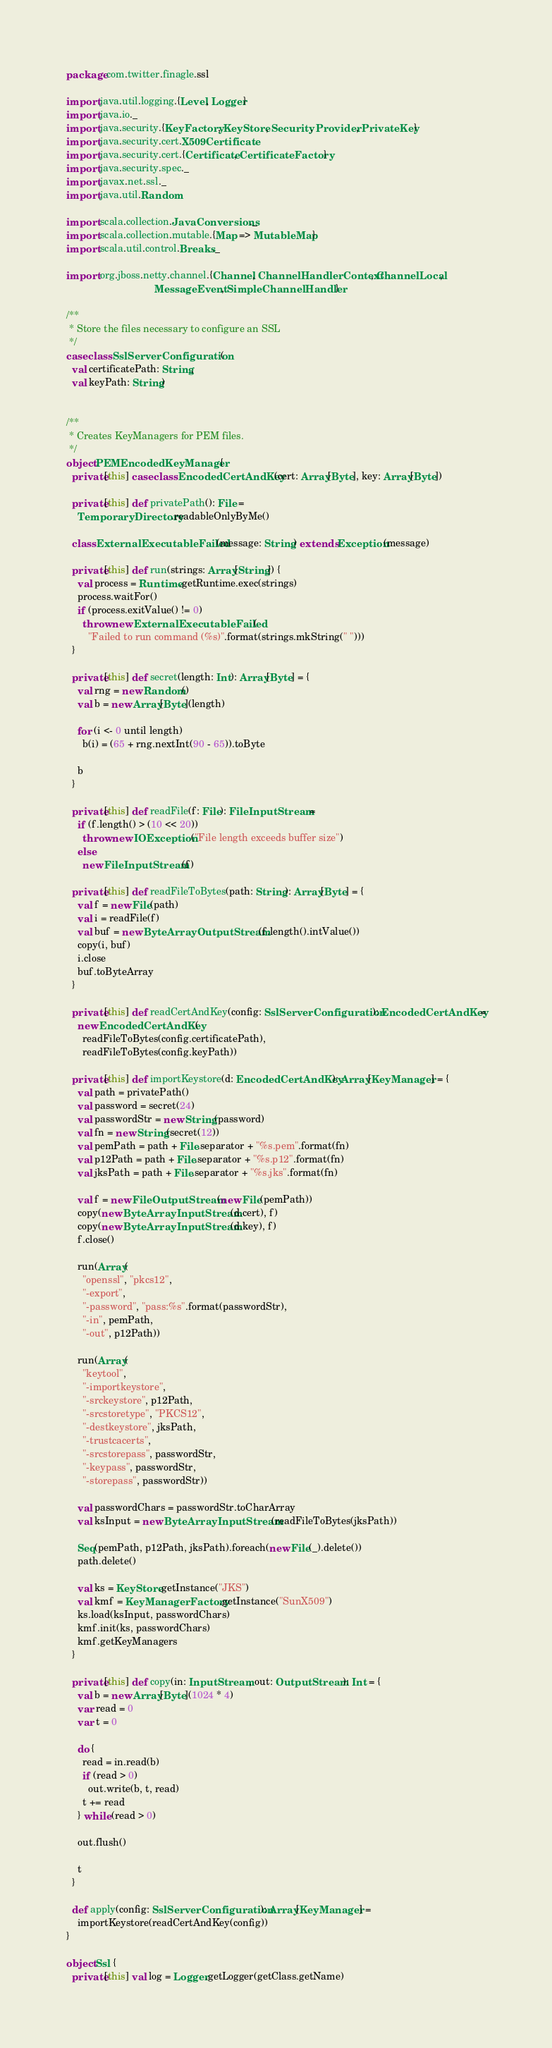Convert code to text. <code><loc_0><loc_0><loc_500><loc_500><_Scala_>package com.twitter.finagle.ssl

import java.util.logging.{Level, Logger}
import java.io._
import java.security.{KeyFactory, KeyStore, Security, Provider, PrivateKey}
import java.security.cert.X509Certificate
import java.security.cert.{Certificate, CertificateFactory}
import java.security.spec._
import javax.net.ssl._
import java.util.Random

import scala.collection.JavaConversions._
import scala.collection.mutable.{Map => MutableMap}
import scala.util.control.Breaks._

import org.jboss.netty.channel.{Channel, ChannelHandlerContext, ChannelLocal,
                                MessageEvent, SimpleChannelHandler}

/**
 * Store the files necessary to configure an SSL
 */
case class SslServerConfiguration(
  val certificatePath: String,
  val keyPath: String)


/**
 * Creates KeyManagers for PEM files.
 */
object PEMEncodedKeyManager {
  private[this] case class EncodedCertAndKey(cert: Array[Byte], key: Array[Byte])

  private[this] def privatePath(): File =
    TemporaryDirectory.readableOnlyByMe()

  class ExternalExecutableFailed(message: String) extends Exception(message)

  private[this] def run(strings: Array[String]) {
    val process = Runtime.getRuntime.exec(strings)
    process.waitFor()
    if (process.exitValue() != 0)
      throw new ExternalExecutableFailed(
        "Failed to run command (%s)".format(strings.mkString(" ")))
  }

  private[this] def secret(length: Int): Array[Byte] = {
    val rng = new Random()
    val b = new Array[Byte](length)

    for (i <- 0 until length)
      b(i) = (65 + rng.nextInt(90 - 65)).toByte

    b
  }

  private[this] def readFile(f: File): FileInputStream =
    if (f.length() > (10 << 20))
      throw new IOException("File length exceeds buffer size")
    else
      new FileInputStream(f)

  private[this] def readFileToBytes(path: String): Array[Byte] = {
    val f = new File(path)
    val i = readFile(f)
    val buf = new ByteArrayOutputStream(f.length().intValue())
    copy(i, buf)
    i.close
    buf.toByteArray
  }

  private[this] def readCertAndKey(config: SslServerConfiguration): EncodedCertAndKey =
    new EncodedCertAndKey(
      readFileToBytes(config.certificatePath),
      readFileToBytes(config.keyPath))

  private[this] def importKeystore(d: EncodedCertAndKey): Array[KeyManager] = {
    val path = privatePath()
    val password = secret(24)
    val passwordStr = new String(password)
    val fn = new String(secret(12))
    val pemPath = path + File.separator + "%s.pem".format(fn)
    val p12Path = path + File.separator + "%s.p12".format(fn)
    val jksPath = path + File.separator + "%s.jks".format(fn)

    val f = new FileOutputStream(new File(pemPath))
    copy(new ByteArrayInputStream(d.cert), f)
    copy(new ByteArrayInputStream(d.key), f)
    f.close()

    run(Array(
      "openssl", "pkcs12",
      "-export",
      "-password", "pass:%s".format(passwordStr),
      "-in", pemPath,
      "-out", p12Path))

    run(Array(
      "keytool",
      "-importkeystore",
      "-srckeystore", p12Path,
      "-srcstoretype", "PKCS12",
      "-destkeystore", jksPath,
      "-trustcacerts",
      "-srcstorepass", passwordStr,
      "-keypass", passwordStr,
      "-storepass", passwordStr))

    val passwordChars = passwordStr.toCharArray
    val ksInput = new ByteArrayInputStream(readFileToBytes(jksPath))

    Seq(pemPath, p12Path, jksPath).foreach(new File(_).delete())
    path.delete()

    val ks = KeyStore.getInstance("JKS")
    val kmf = KeyManagerFactory.getInstance("SunX509")
    ks.load(ksInput, passwordChars)
    kmf.init(ks, passwordChars)
    kmf.getKeyManagers
  }

  private[this] def copy(in: InputStream, out: OutputStream): Int = {
    val b = new Array[Byte](1024 * 4)
    var read = 0
    var t = 0

    do {
      read = in.read(b)
      if (read > 0)
        out.write(b, t, read)
      t += read
    } while (read > 0)

    out.flush()

    t
  }

  def apply(config: SslServerConfiguration): Array[KeyManager] =
    importKeystore(readCertAndKey(config))
}

object Ssl {
  private[this] val log = Logger.getLogger(getClass.getName)</code> 